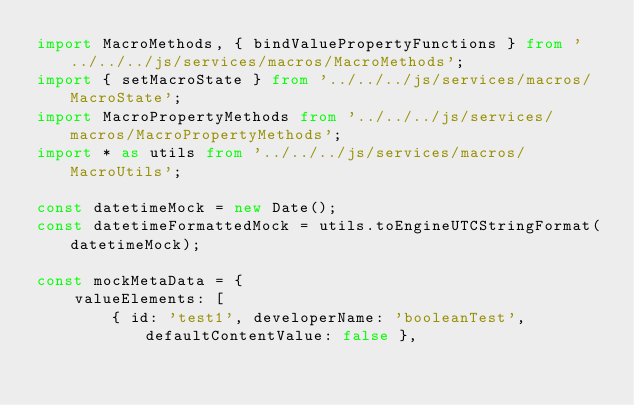<code> <loc_0><loc_0><loc_500><loc_500><_TypeScript_>import MacroMethods, { bindValuePropertyFunctions } from '../../../js/services/macros/MacroMethods';
import { setMacroState } from '../../../js/services/macros/MacroState';
import MacroPropertyMethods from '../../../js/services/macros/MacroPropertyMethods';
import * as utils from '../../../js/services/macros/MacroUtils';

const datetimeMock = new Date();
const datetimeFormattedMock = utils.toEngineUTCStringFormat(datetimeMock);

const mockMetaData = {
    valueElements: [
        { id: 'test1', developerName: 'booleanTest', defaultContentValue: false },</code> 